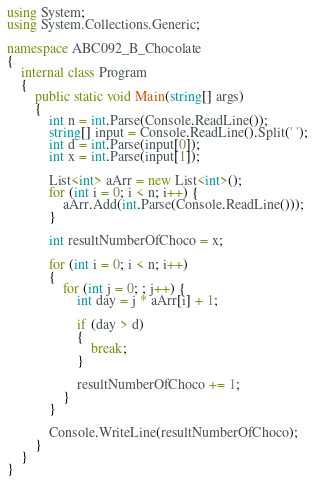Convert code to text. <code><loc_0><loc_0><loc_500><loc_500><_C#_>using System;
using System.Collections.Generic;

namespace ABC092_B_Chocolate
{
	internal class Program
	{
		public static void Main(string[] args)
		{
			int n = int.Parse(Console.ReadLine());
			string[] input = Console.ReadLine().Split(' ');
			int d = int.Parse(input[0]);
			int x = int.Parse(input[1]);

			List<int> aArr = new List<int>();
			for (int i = 0; i < n; i++) {
				aArr.Add(int.Parse(Console.ReadLine()));
			}
			
			int resultNumberOfChoco = x;

			for (int i = 0; i < n; i++)
			{
				for (int j = 0; ; j++) {
					int day = j * aArr[i] + 1;

					if (day > d)
					{
						break;
					}

					resultNumberOfChoco += 1;
				}
			}
			
			Console.WriteLine(resultNumberOfChoco);
		}
	}
}</code> 